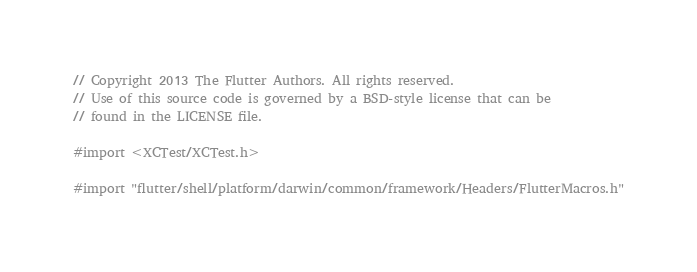Convert code to text. <code><loc_0><loc_0><loc_500><loc_500><_ObjectiveC_>// Copyright 2013 The Flutter Authors. All rights reserved.
// Use of this source code is governed by a BSD-style license that can be
// found in the LICENSE file.

#import <XCTest/XCTest.h>

#import "flutter/shell/platform/darwin/common/framework/Headers/FlutterMacros.h"</code> 